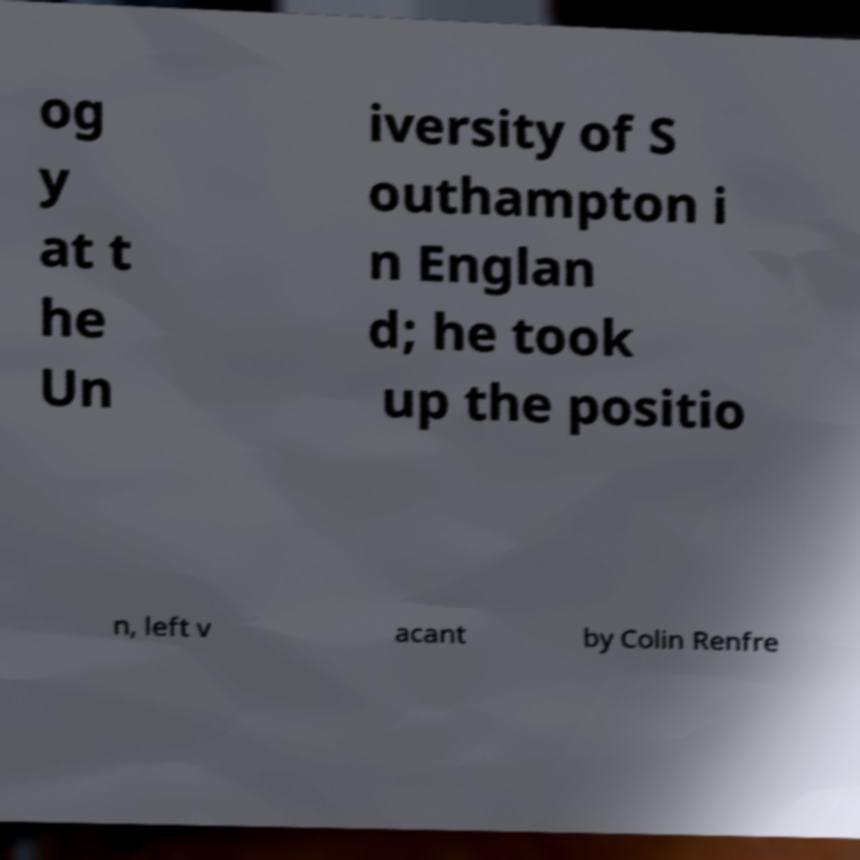For documentation purposes, I need the text within this image transcribed. Could you provide that? og y at t he Un iversity of S outhampton i n Englan d; he took up the positio n, left v acant by Colin Renfre 